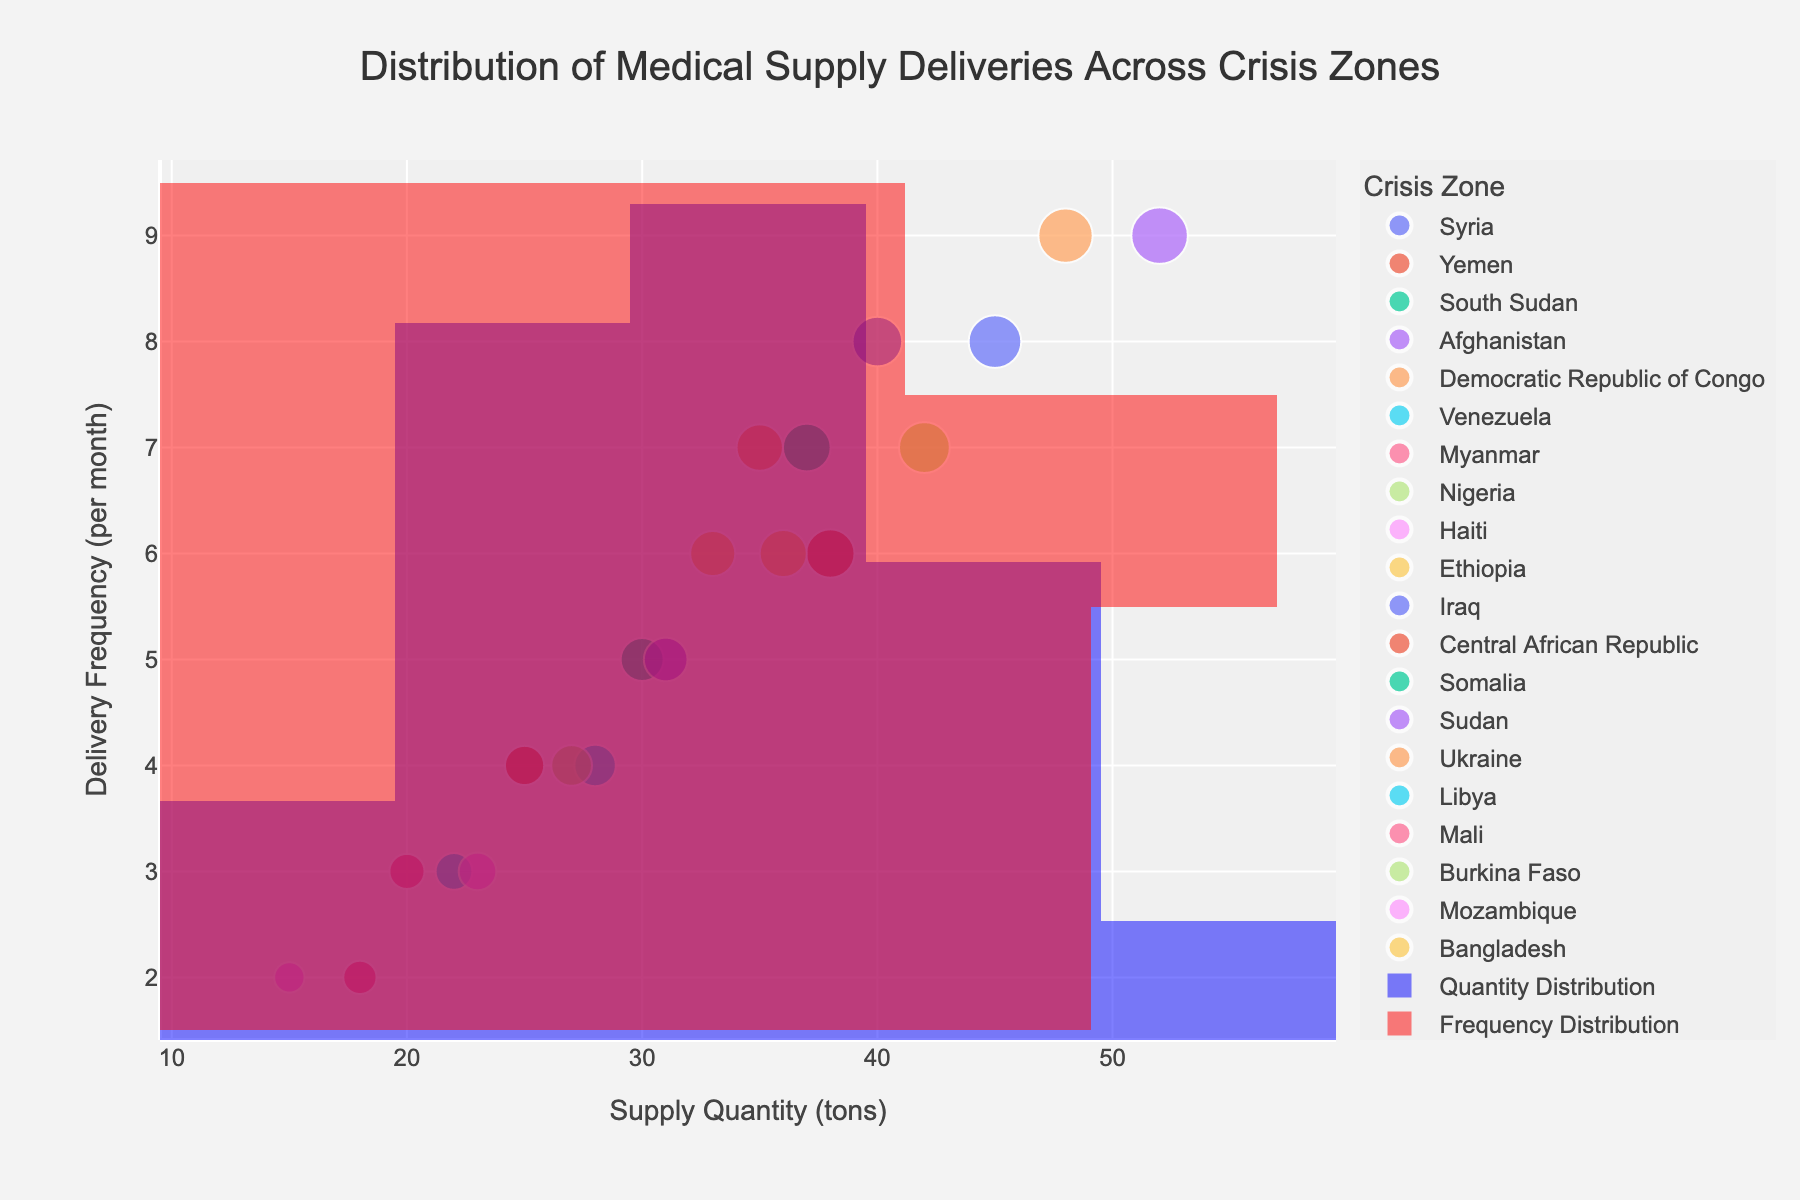How many crisis zones are displayed in the plot? To determine the number of crisis zones, count the distinct markers (each representing a different color/zone) in the scatterplot.
Answer: 20 What is the title of the figure? Read the title text provided at the top of the figure.
Answer: Distribution of Medical Supply Deliveries Across Crisis Zones Which crisis zone received the highest quantity of medical supplies? Identify the data point with the largest size marker and check its hover data or label; it's the one with the highest 'Quantity (tons)'.
Answer: Afghanistan How is the x-axis labeled? Read the label along the horizontal (x) axis of the figure.
Answer: Supply Quantity (tons) Which crisis zone has the highest delivery frequency but not the highest quantity? Find the highest point on the y-axis that is not the largest in size. Review its hover or textual information to confirm the corresponding zone.
Answer: Ukraine What is the range of 'Frequency (deliveries per month)' values present in the plot? Review the minimum and maximum values along the y-axis to determine the range of delivery frequency.
Answer: 2 to 9 Are there more deliveries in zones with higher supply quantities? Analyze the trend from left to right in the scatter plot to see if data points rise upwards, indicating a positive correlation.
Answer: Typically yes What is the most common delivery frequency among the crisis zones? Identify the y-coordinate where there are the most data points stacked vertically.
Answer: 6 deliveries per month Which two crisis zones have nearly the same supply quantity but different delivery frequencies? Look for vertically aligned markers that have varying y-axis values but similar sizes. Verify with hover data to confirm the zones.
Answer: Ethiopia and Democratic Republic of Congo What additional information do the marginal histograms provide? Examine the marginal histograms displayed above and beside the scatter plot; they give an aggregated view of distribution for both quantity and frequency.
Answer: Distribution of supply quantities and delivery frequencies 